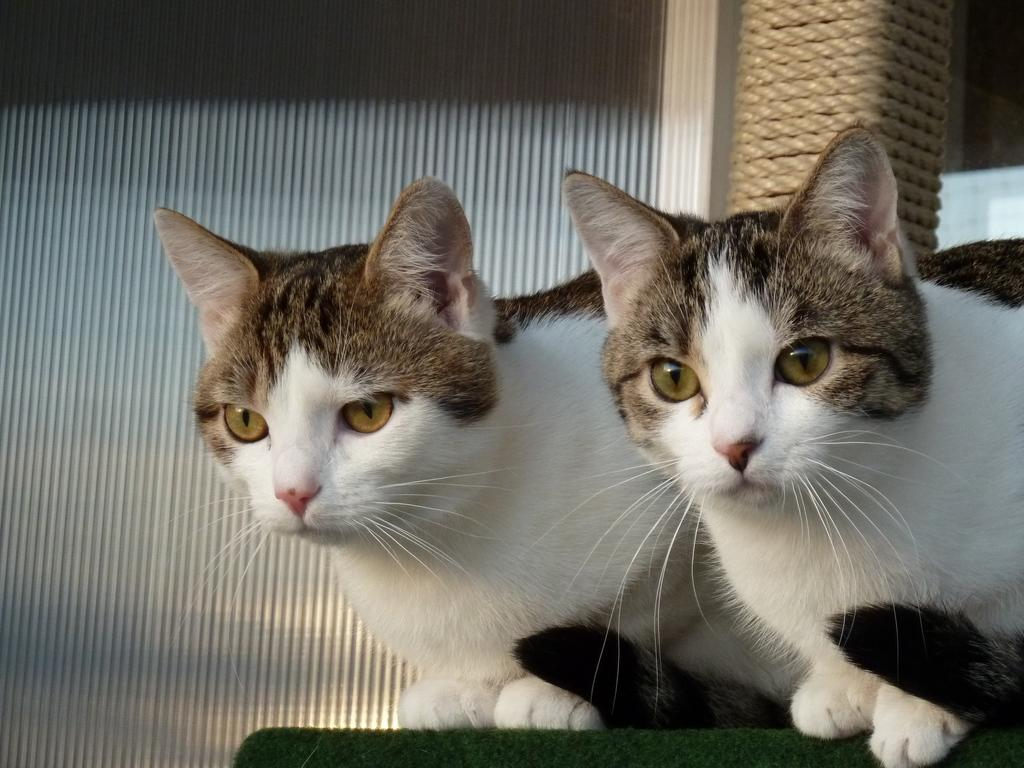What color is the surface at the bottom of the image? The surface at the bottom of the image is green. What animals can be seen in the foreground of the image? There are two cats sitting in the foreground of the image. What can be seen in the background of the image? There is a window blind in the background of the image. What news is being reported on the television in the image? There is no television present in the image, so it is not possible to determine what news might be reported. 